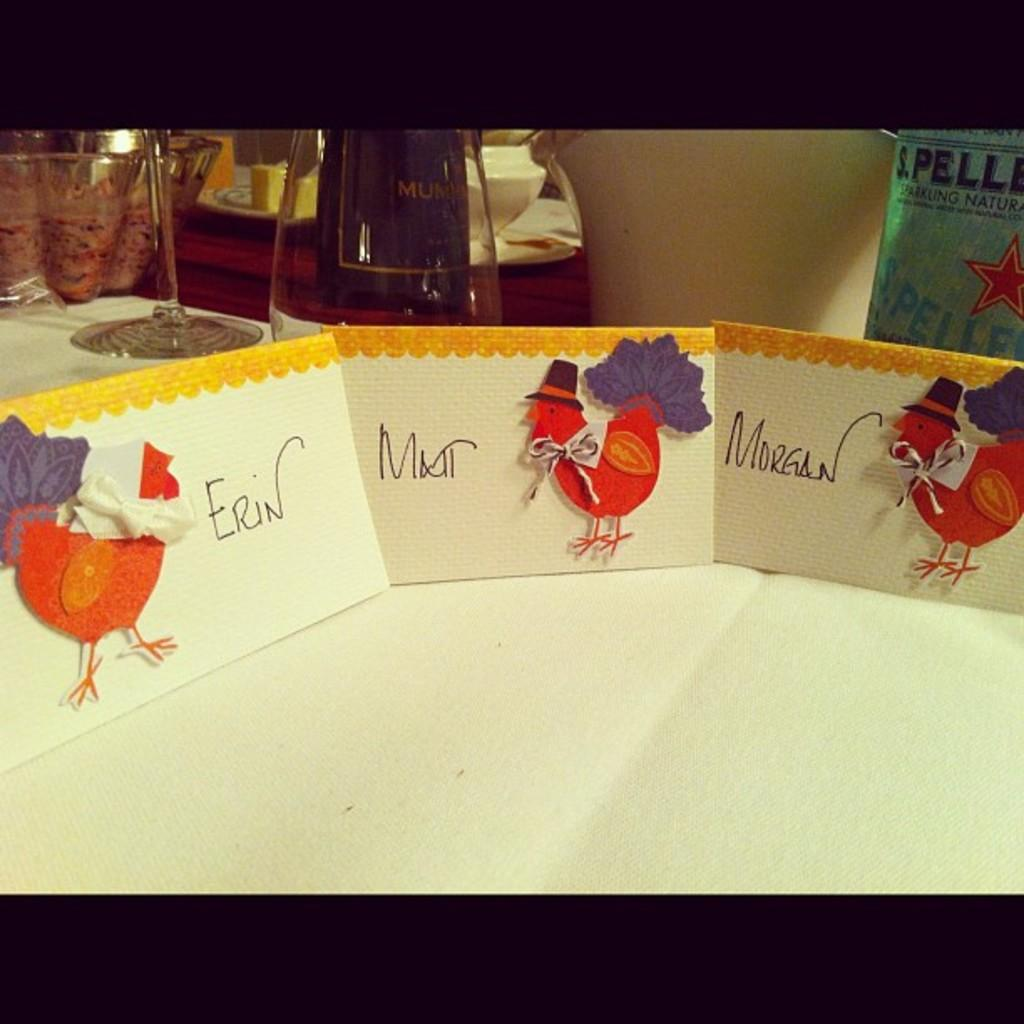<image>
Summarize the visual content of the image. cards with turkeys on them and names Erin, and Morgan 